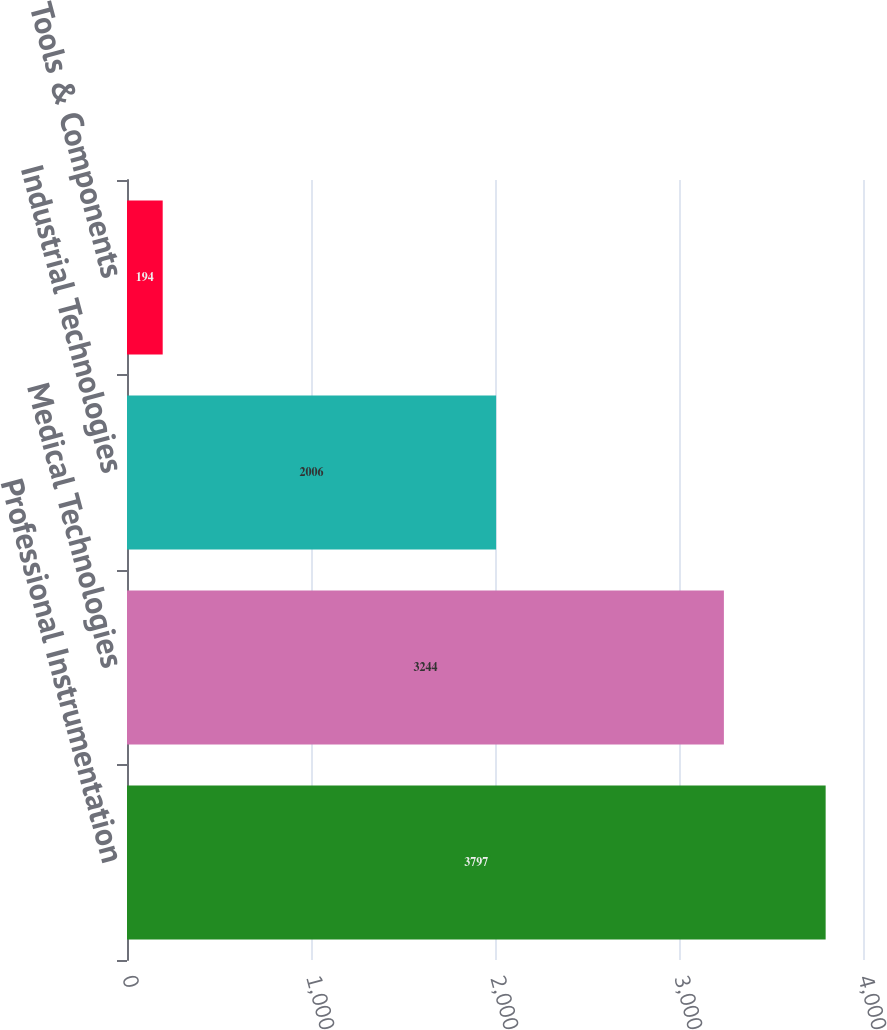Convert chart to OTSL. <chart><loc_0><loc_0><loc_500><loc_500><bar_chart><fcel>Professional Instrumentation<fcel>Medical Technologies<fcel>Industrial Technologies<fcel>Tools & Components<nl><fcel>3797<fcel>3244<fcel>2006<fcel>194<nl></chart> 